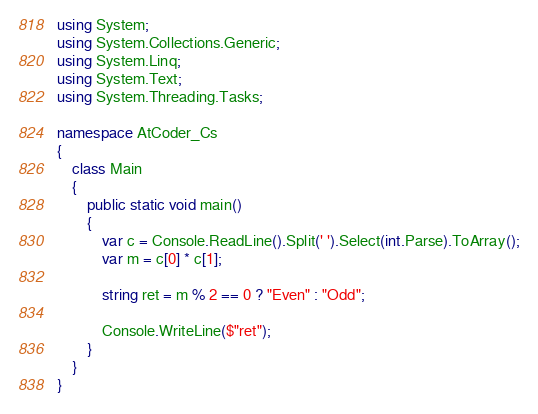Convert code to text. <code><loc_0><loc_0><loc_500><loc_500><_C#_>using System;
using System.Collections.Generic;
using System.Linq;
using System.Text;
using System.Threading.Tasks;

namespace AtCoder_Cs
{
    class Main
    {
        public static void main()
        {
            var c = Console.ReadLine().Split(' ').Select(int.Parse).ToArray();
            var m = c[0] * c[1];

            string ret = m % 2 == 0 ? "Even" : "Odd";

            Console.WriteLine($"ret");
        }
    }
}
</code> 